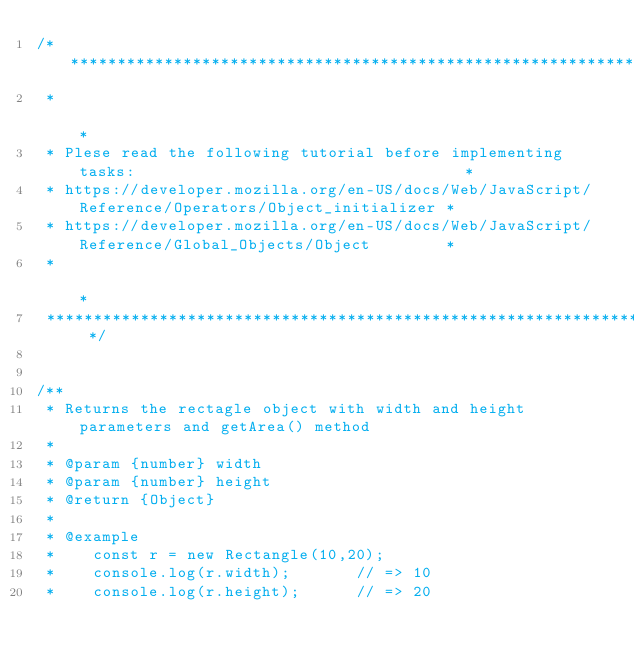<code> <loc_0><loc_0><loc_500><loc_500><_JavaScript_>/* ************************************************************************************************
 *                                                                                                *
 * Plese read the following tutorial before implementing tasks:                                   *
 * https://developer.mozilla.org/en-US/docs/Web/JavaScript/Reference/Operators/Object_initializer *
 * https://developer.mozilla.org/en-US/docs/Web/JavaScript/Reference/Global_Objects/Object        *
 *                                                                                                *
 ************************************************************************************************ */


/**
 * Returns the rectagle object with width and height parameters and getArea() method
 *
 * @param {number} width
 * @param {number} height
 * @return {Object}
 *
 * @example
 *    const r = new Rectangle(10,20);
 *    console.log(r.width);       // => 10
 *    console.log(r.height);      // => 20</code> 